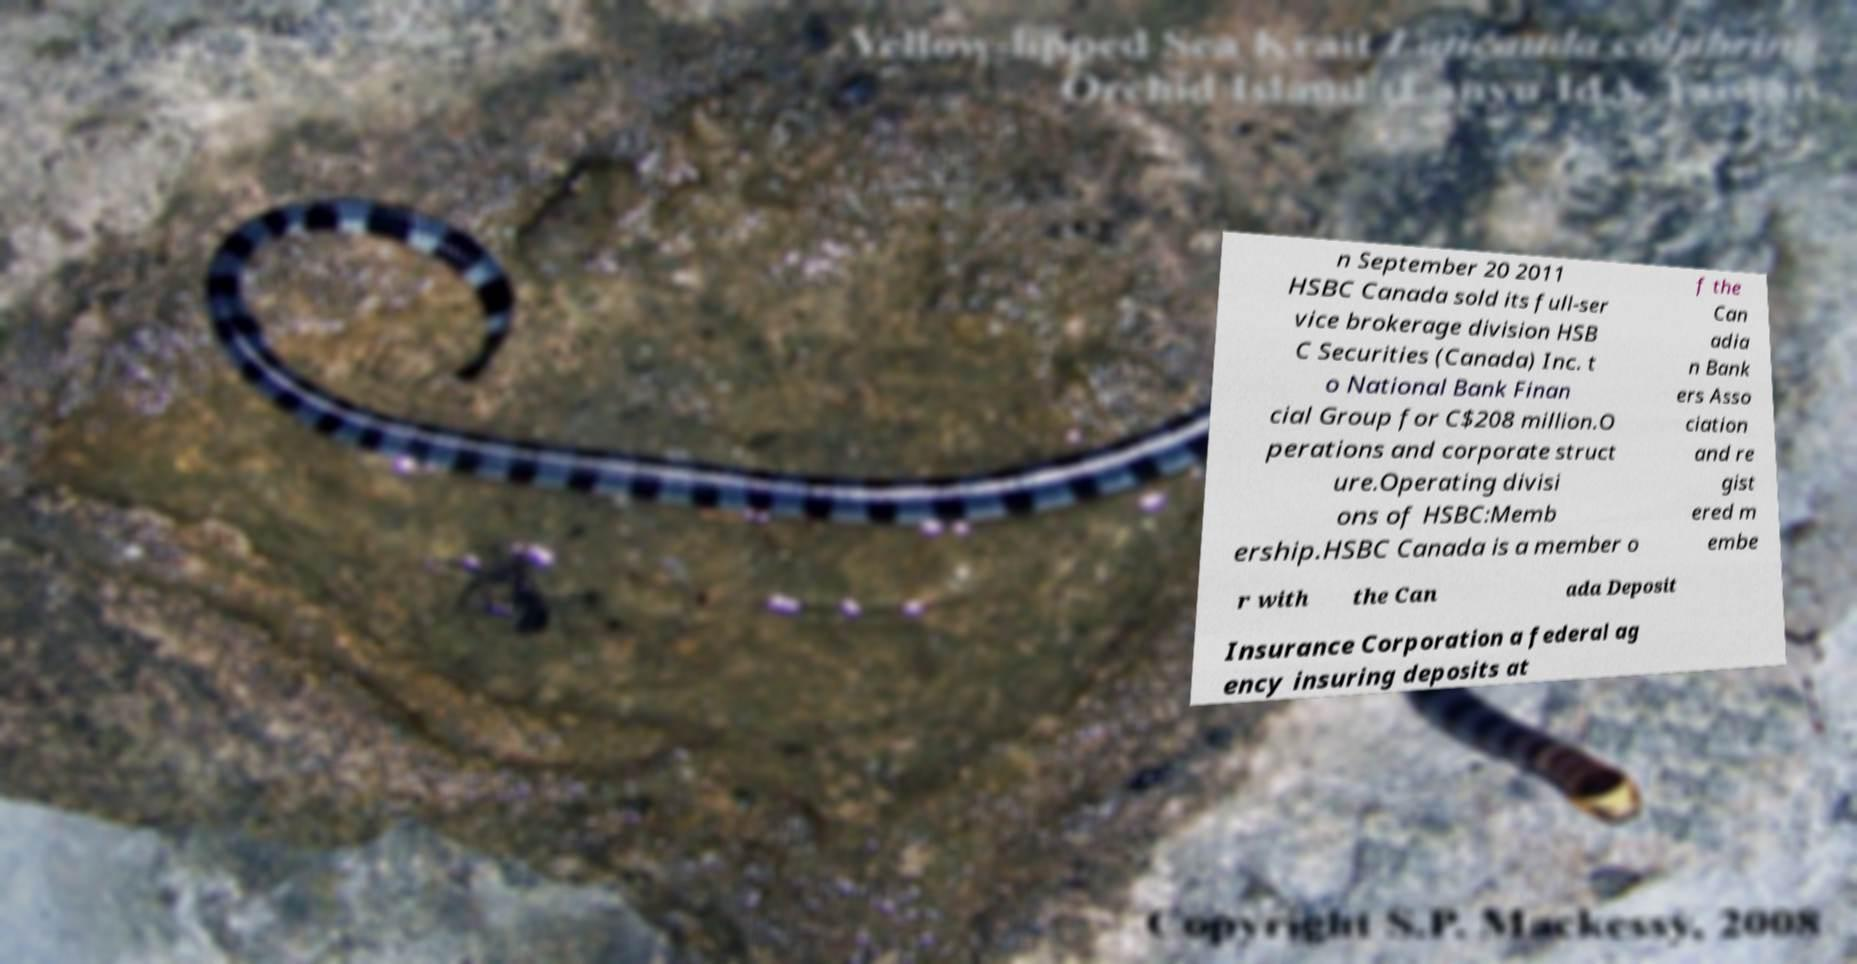I need the written content from this picture converted into text. Can you do that? n September 20 2011 HSBC Canada sold its full-ser vice brokerage division HSB C Securities (Canada) Inc. t o National Bank Finan cial Group for C$208 million.O perations and corporate struct ure.Operating divisi ons of HSBC:Memb ership.HSBC Canada is a member o f the Can adia n Bank ers Asso ciation and re gist ered m embe r with the Can ada Deposit Insurance Corporation a federal ag ency insuring deposits at 